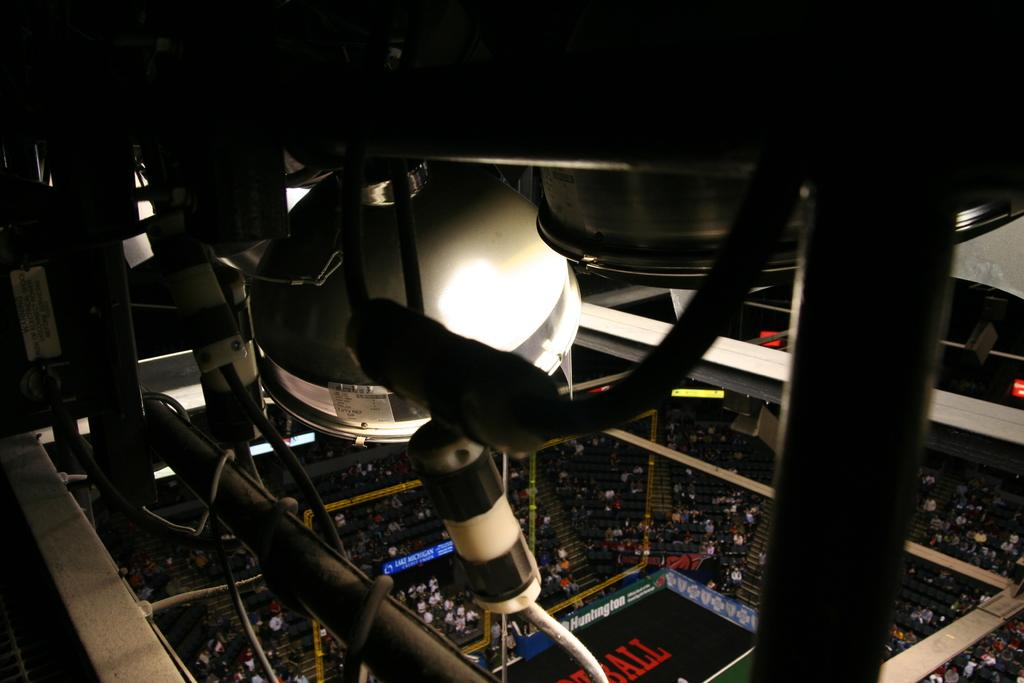What type of location is depicted in the image? The image appears to depict an indoor stadium. Can you describe any people visible in the image? Yes, there are people visible in the image. What type of cabbage is being used as a seat cushion in the image? There is no cabbage present in the image, and therefore no such use can be observed. 